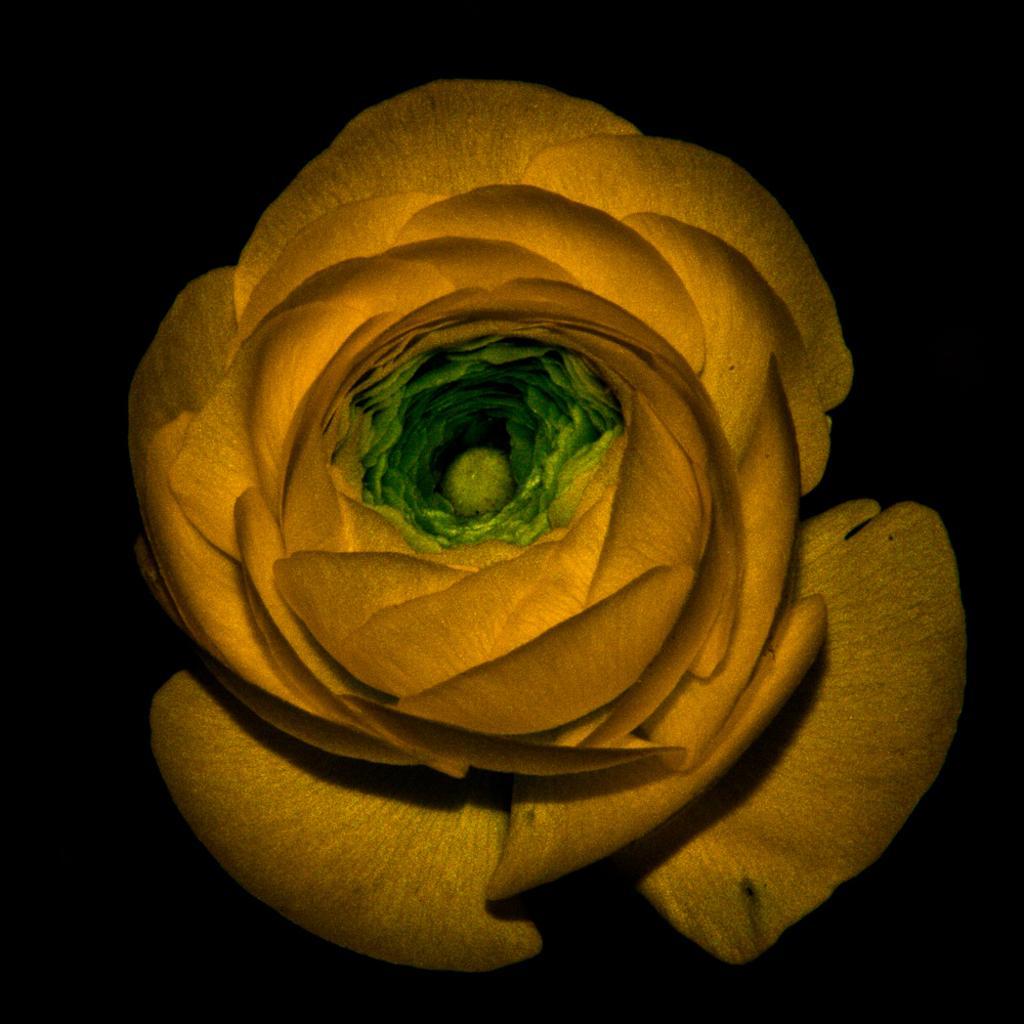How would you summarize this image in a sentence or two? In this image there is an object which is yellow and green in colour. 